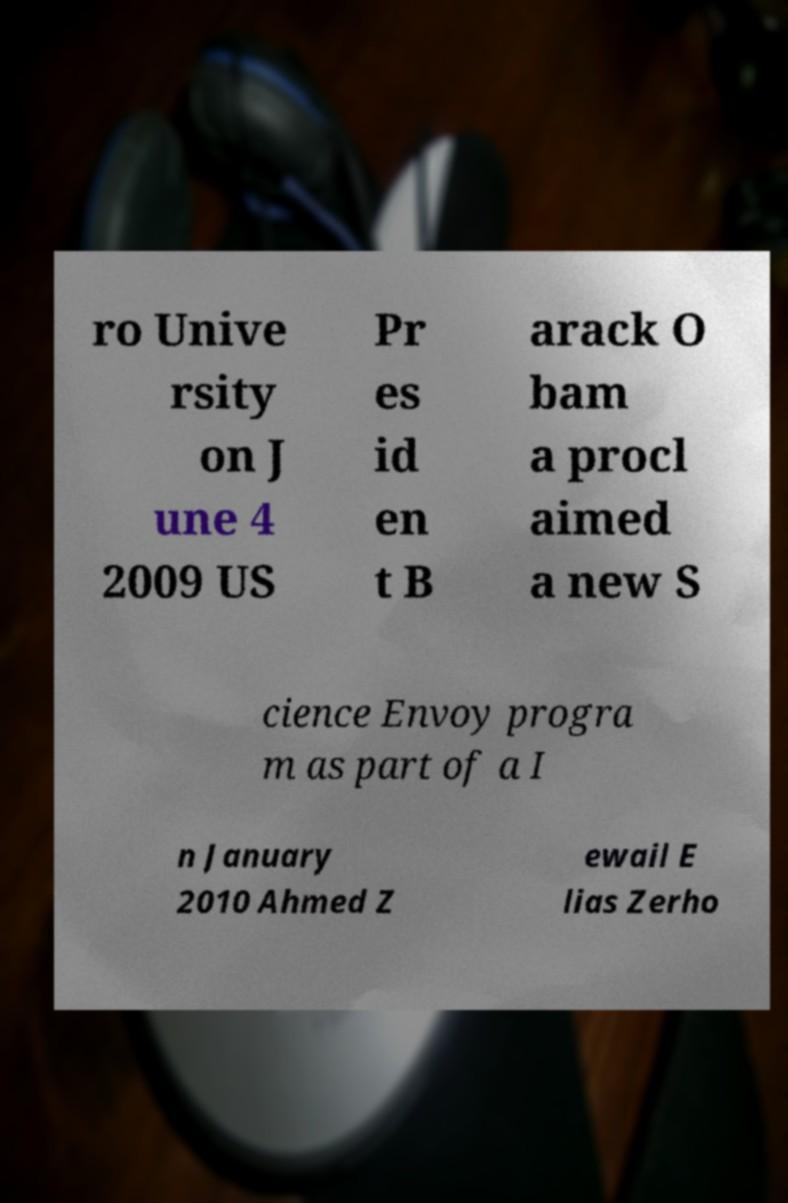Could you extract and type out the text from this image? ro Unive rsity on J une 4 2009 US Pr es id en t B arack O bam a procl aimed a new S cience Envoy progra m as part of a I n January 2010 Ahmed Z ewail E lias Zerho 